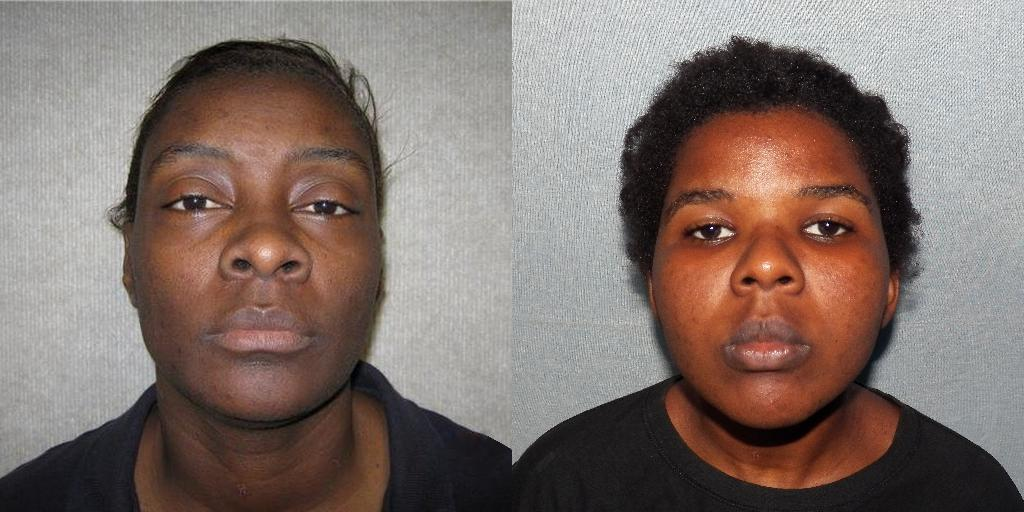What type of image is being described? The image is a collage. How many people are present in the collage? There are two persons in the collage. What color is the background of the collage? The background of the collage is white. What type of authority is depicted in the collage? There is no authority figure depicted in the collage; it features two persons and a white background. How does the toothpaste contribute to the collage's composition? There is no toothpaste present in the collage; it is a collage of two persons with a white background. 